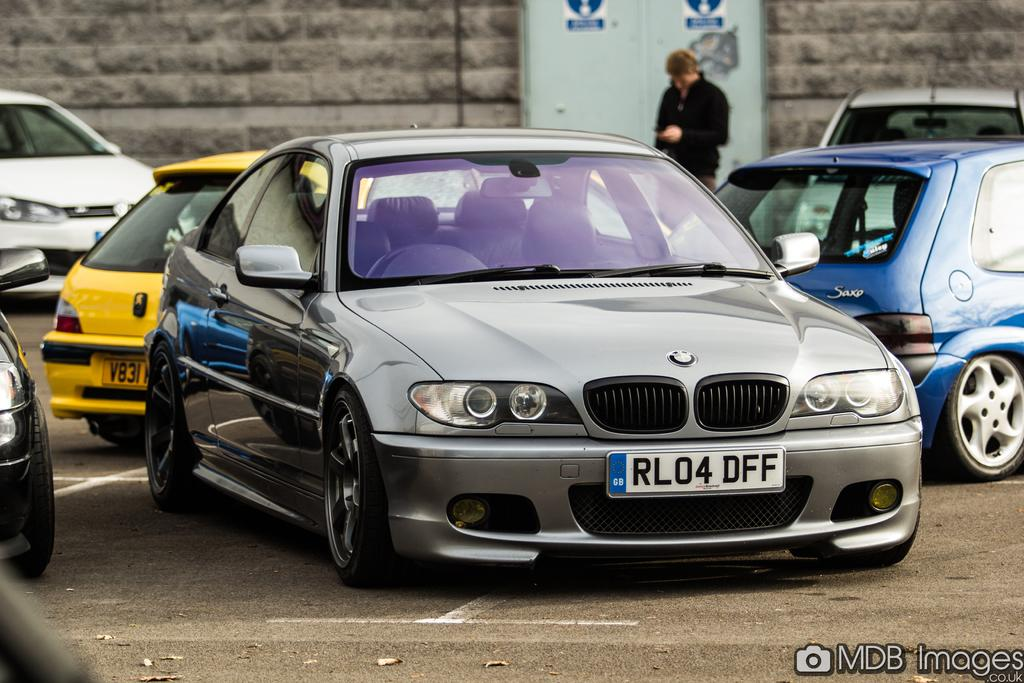Provide a one-sentence caption for the provided image. A silver BMW with the license plate of RL04 DFF. 